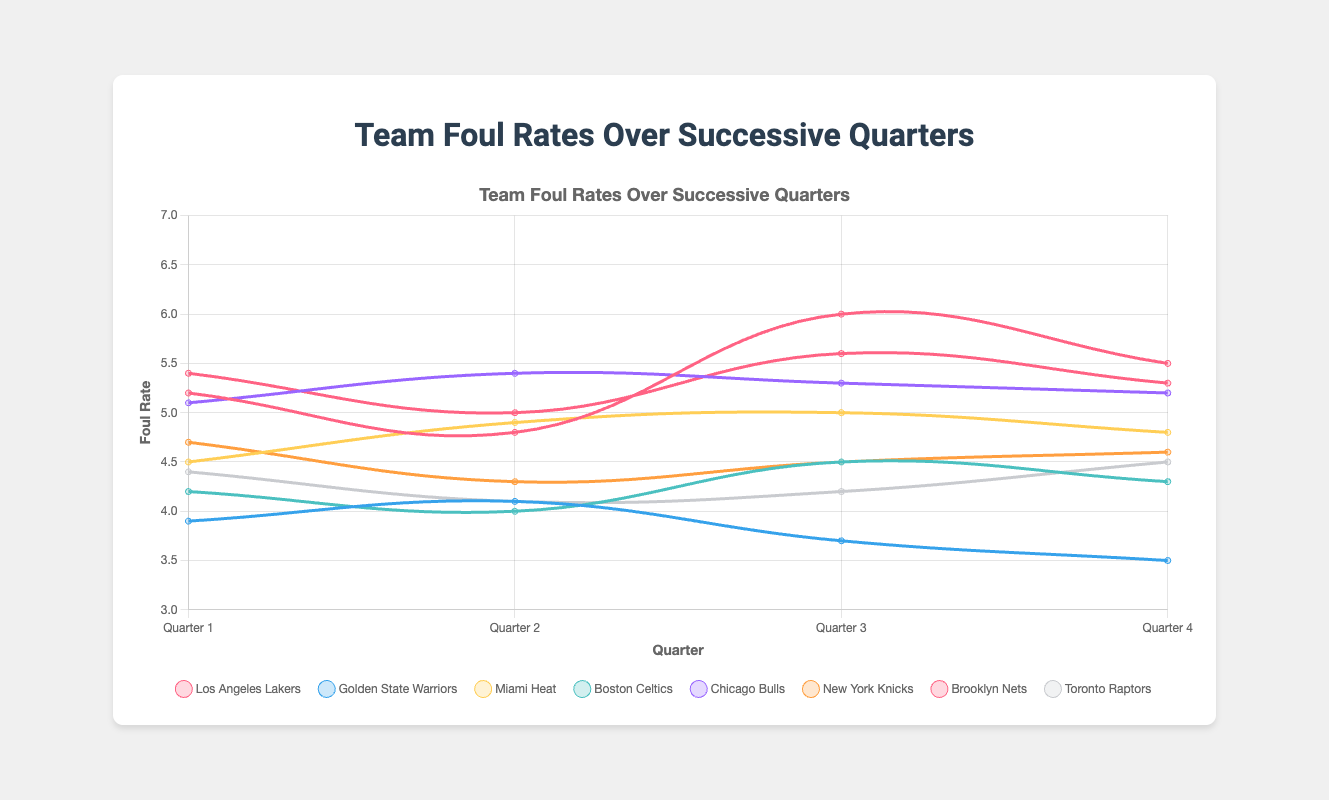What trend can be observed in the foul rates of the Los Angeles Lakers from quarter 1 to quarter 4? Observing the trend for the Los Angeles Lakers, we see that the foul rate decreases from 5.2 in quarter 1 to 4.8 in quarter 2, then increases to 6.0 in quarter 3, and finally decreases to 5.5 in quarter 4.
Answer: Decrease, Increase, Decrease Which team had the highest foul rate in quarter 3? Comparing the foul rates in quarter 3 across all teams, the Brooklyn Nets had the highest foul rate with a value of 5.6.
Answer: Brooklyn Nets Which team had the most consistent foul rates across all four quarters? To determine the team with the most consistent foul rates, we look at the fluctuations in foul rates for each team. The Golden State Warriors' foul rates range from 3.9 to 4.1, which is relatively small compared to other teams.
Answer: Golden State Warriors What is the difference between the foul rates of the Miami Heat and Boston Celtics in quarter 2? The foul rate of the Miami Heat in quarter 2 is 4.9, and the Boston Celtics have a foul rate of 4.0 in the same quarter. The difference is 4.9 - 4.0 = 0.9.
Answer: 0.9 What is the average foul rate for the Chicago Bulls across all four quarters? The foul rates for the Chicago Bulls across the four quarters in Game 3 are 5.1, 5.4, 5.3, and 5.2. The average is (5.1 + 5.4 + 5.3 + 5.2) / 4 = 21 / 4 = 5.25.
Answer: 5.25 How does the foul rate of the New York Knicks in quarter 4 compare to their foul rate in quarter 1? The foul rate of the New York Knicks in quarter 4 is 4.6, while in quarter 1 it is 4.7. Therefore, it slightly decreases from quarter 1 to quarter 4.
Answer: Decreases Which quarter shows the highest variability in foul rates among all teams? To determine the quarter with the highest variability, we must compare the range of foul rates in each quarter. The ranges are: Quarter 1: (5.4 - 3.9), Quarter 2: (5.4 - 4.0), Quarter 3: (6.0 - 3.7), Quarter 4: (5.5 - 3.5). Quarter 3 has the highest range (6.0 - 3.7 = 2.3).
Answer: Quarter 3 What is the median foul rate for the Toronto Raptors over the four quarters? The foul rates for the Toronto Raptors are 4.4, 4.1, 4.2, and 4.5. Arranging them in order gives: 4.1, 4.2, 4.4, 4.5. The median is the average of the two middle values, (4.2 + 4.4) / 2 = 4.3.
Answer: 4.3 Do any teams have a consistently increasing or decreasing foul rate across the four quarters? Observing the foul rates of all the teams, the Golden State Warriors show a consistently decreasing foul rate across all four quarters (3.9, 4.1, 3.7, 3.5).
Answer: Golden State Warriors 